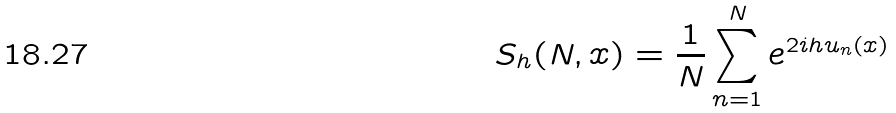Convert formula to latex. <formula><loc_0><loc_0><loc_500><loc_500>S _ { h } ( N , x ) = \frac { 1 } { N } \sum _ { n = 1 } ^ { N } e ^ { 2 i h u _ { n } ( x ) }</formula> 